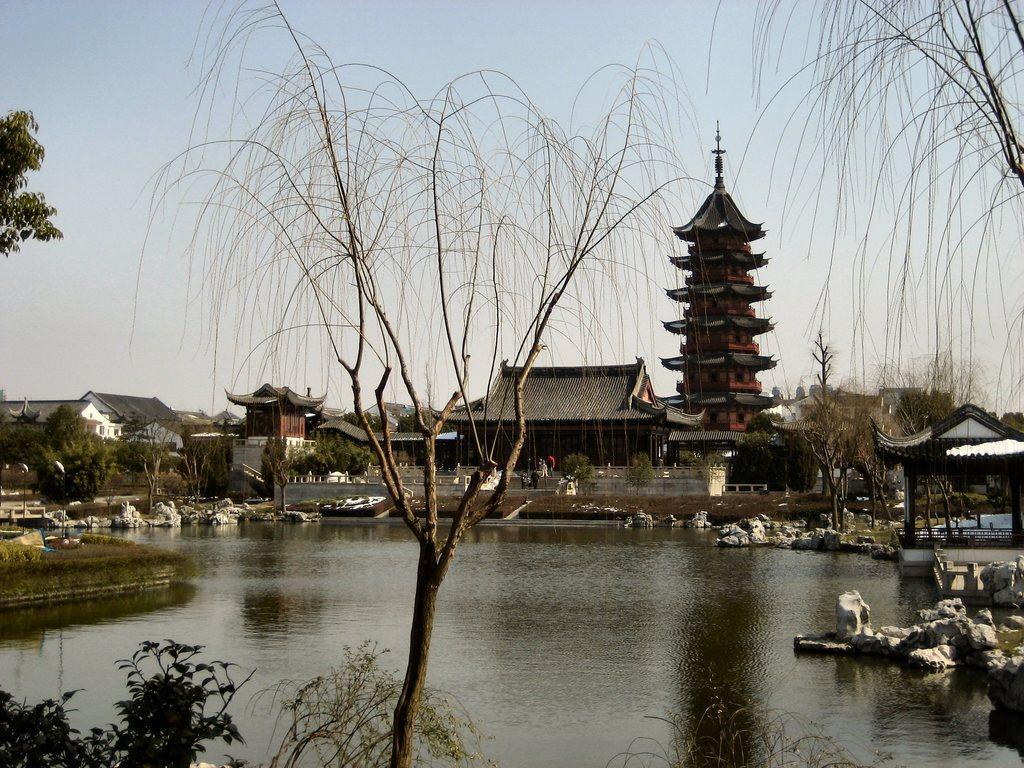In one or two sentences, can you explain what this image depicts? In this image I can see water in the centre and around it I can see number of trees. In the background I can see few buildings, the sky and on the right side of this image I can see a shed. 